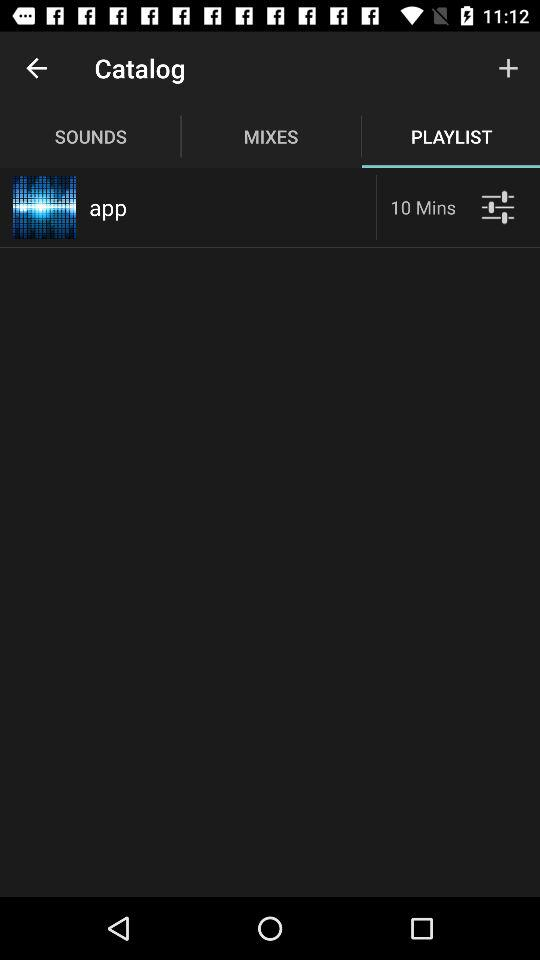What is the given time in minutes? The given time is 10 minutes. 